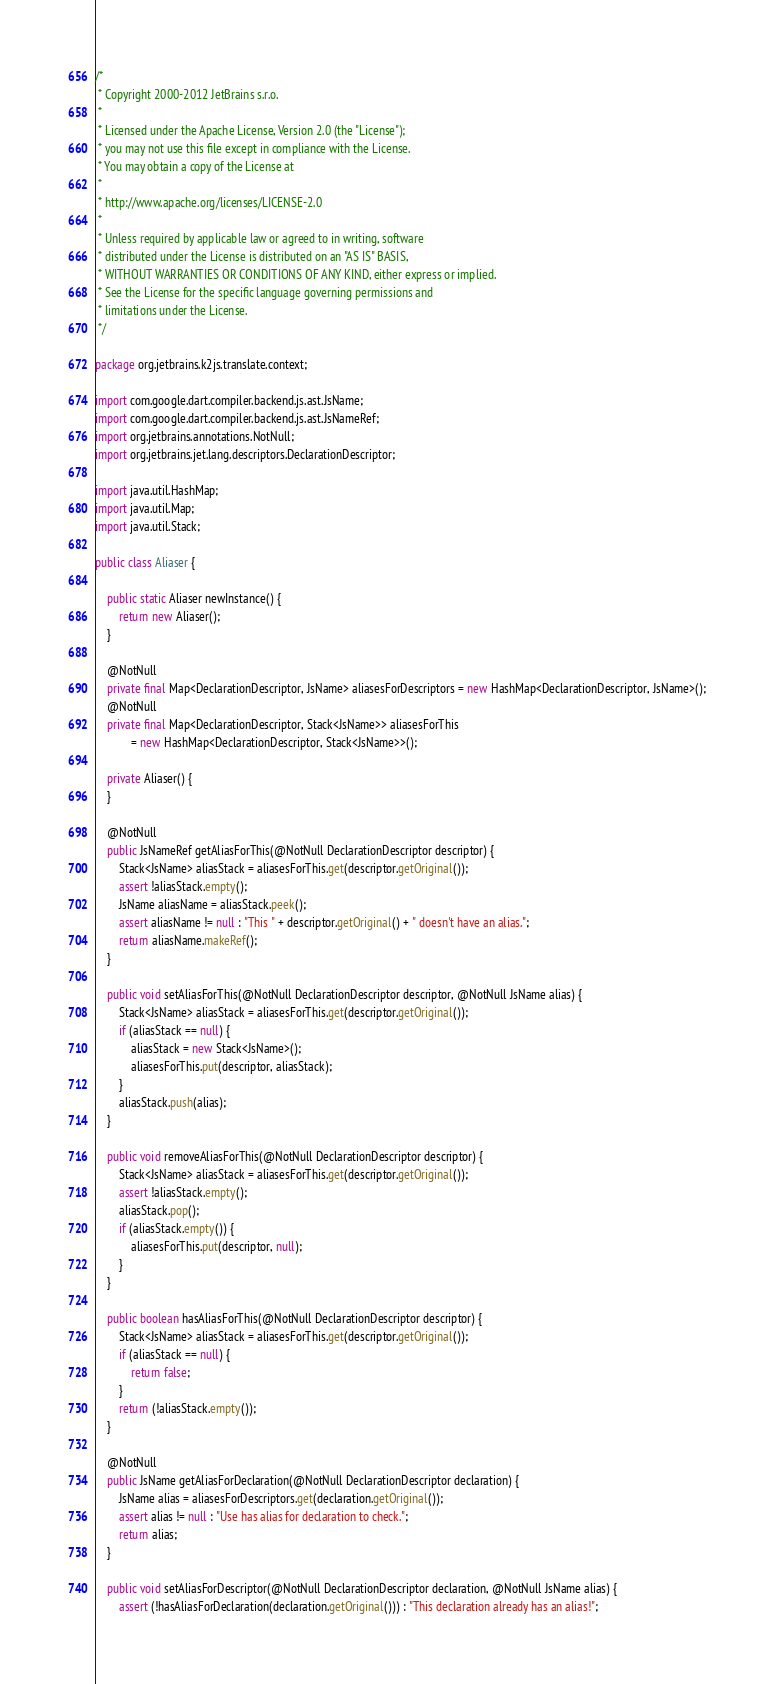<code> <loc_0><loc_0><loc_500><loc_500><_Java_>/*
 * Copyright 2000-2012 JetBrains s.r.o.
 *
 * Licensed under the Apache License, Version 2.0 (the "License");
 * you may not use this file except in compliance with the License.
 * You may obtain a copy of the License at
 *
 * http://www.apache.org/licenses/LICENSE-2.0
 *
 * Unless required by applicable law or agreed to in writing, software
 * distributed under the License is distributed on an "AS IS" BASIS,
 * WITHOUT WARRANTIES OR CONDITIONS OF ANY KIND, either express or implied.
 * See the License for the specific language governing permissions and
 * limitations under the License.
 */

package org.jetbrains.k2js.translate.context;

import com.google.dart.compiler.backend.js.ast.JsName;
import com.google.dart.compiler.backend.js.ast.JsNameRef;
import org.jetbrains.annotations.NotNull;
import org.jetbrains.jet.lang.descriptors.DeclarationDescriptor;

import java.util.HashMap;
import java.util.Map;
import java.util.Stack;

public class Aliaser {

    public static Aliaser newInstance() {
        return new Aliaser();
    }

    @NotNull
    private final Map<DeclarationDescriptor, JsName> aliasesForDescriptors = new HashMap<DeclarationDescriptor, JsName>();
    @NotNull
    private final Map<DeclarationDescriptor, Stack<JsName>> aliasesForThis
            = new HashMap<DeclarationDescriptor, Stack<JsName>>();

    private Aliaser() {
    }

    @NotNull
    public JsNameRef getAliasForThis(@NotNull DeclarationDescriptor descriptor) {
        Stack<JsName> aliasStack = aliasesForThis.get(descriptor.getOriginal());
        assert !aliasStack.empty();
        JsName aliasName = aliasStack.peek();
        assert aliasName != null : "This " + descriptor.getOriginal() + " doesn't have an alias.";
        return aliasName.makeRef();
    }

    public void setAliasForThis(@NotNull DeclarationDescriptor descriptor, @NotNull JsName alias) {
        Stack<JsName> aliasStack = aliasesForThis.get(descriptor.getOriginal());
        if (aliasStack == null) {
            aliasStack = new Stack<JsName>();
            aliasesForThis.put(descriptor, aliasStack);
        }
        aliasStack.push(alias);
    }

    public void removeAliasForThis(@NotNull DeclarationDescriptor descriptor) {
        Stack<JsName> aliasStack = aliasesForThis.get(descriptor.getOriginal());
        assert !aliasStack.empty();
        aliasStack.pop();
        if (aliasStack.empty()) {
            aliasesForThis.put(descriptor, null);
        }
    }

    public boolean hasAliasForThis(@NotNull DeclarationDescriptor descriptor) {
        Stack<JsName> aliasStack = aliasesForThis.get(descriptor.getOriginal());
        if (aliasStack == null) {
            return false;
        }
        return (!aliasStack.empty());
    }

    @NotNull
    public JsName getAliasForDeclaration(@NotNull DeclarationDescriptor declaration) {
        JsName alias = aliasesForDescriptors.get(declaration.getOriginal());
        assert alias != null : "Use has alias for declaration to check.";
        return alias;
    }

    public void setAliasForDescriptor(@NotNull DeclarationDescriptor declaration, @NotNull JsName alias) {
        assert (!hasAliasForDeclaration(declaration.getOriginal())) : "This declaration already has an alias!";</code> 